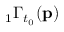<formula> <loc_0><loc_0><loc_500><loc_500>{ } _ { 1 } \Gamma _ { t _ { 0 } } ( p )</formula> 